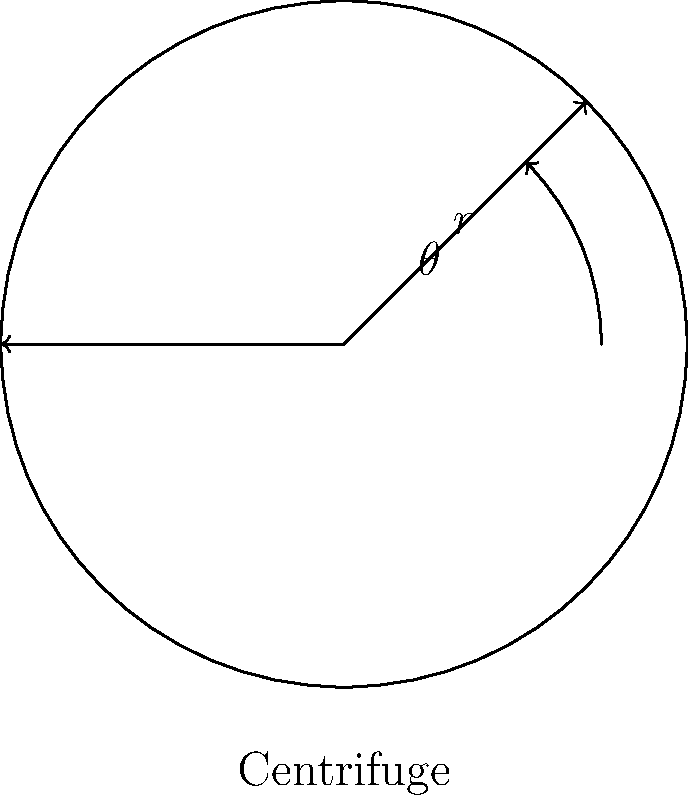In your genetic sequencing lab, you're using a centrifuge to separate DNA fragments. The centrifuge rotor starts from a horizontal position and rotates counterclockwise. If the radius of the rotor is 15 cm and a DNA sample has moved 10.6 cm vertically from its starting position, what is the angle of rotation $\theta$ in degrees? To solve this problem, we can use trigonometric functions, specifically the sine function. Here's a step-by-step approach:

1) In a right-angled triangle formed by the rotor's radius and the vertical displacement, we have:
   - The hypotenuse (radius of the rotor) = 15 cm
   - The opposite side (vertical displacement) = 10.6 cm
   - The angle of rotation $\theta$ (which we need to find)

2) The sine of an angle in a right-angled triangle is defined as:

   $\sin(\theta) = \frac{\text{opposite}}{\text{hypotenuse}}$

3) Substituting our known values:

   $\sin(\theta) = \frac{10.6}{15}$

4) To find $\theta$, we need to take the inverse sine (arcsin) of both sides:

   $\theta = \arcsin(\frac{10.6}{15})$

5) Using a calculator or computer to evaluate this:

   $\theta \approx 44.7^\circ$

Thus, the angle of rotation is approximately 44.7 degrees.
Answer: $44.7^\circ$ 